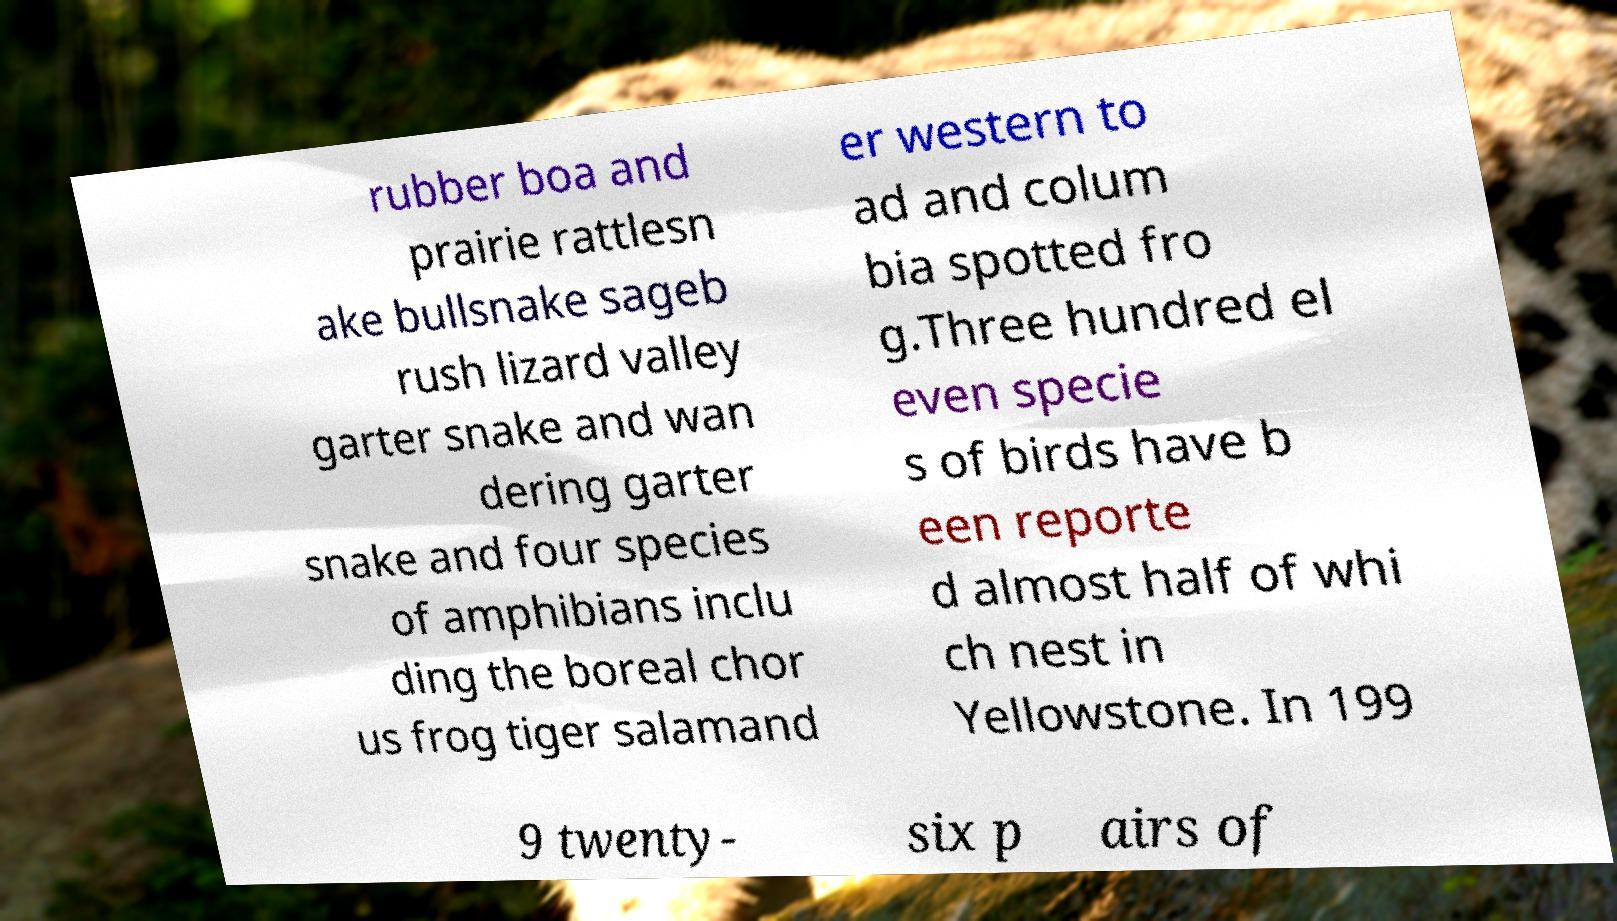Please read and relay the text visible in this image. What does it say? rubber boa and prairie rattlesn ake bullsnake sageb rush lizard valley garter snake and wan dering garter snake and four species of amphibians inclu ding the boreal chor us frog tiger salamand er western to ad and colum bia spotted fro g.Three hundred el even specie s of birds have b een reporte d almost half of whi ch nest in Yellowstone. In 199 9 twenty- six p airs of 